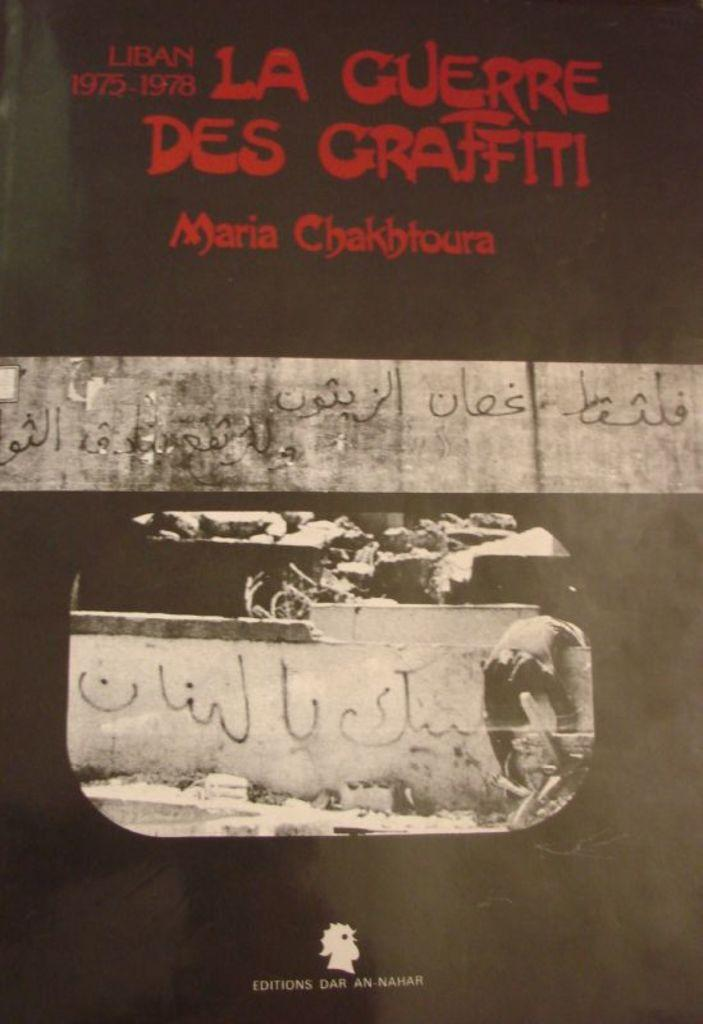<image>
Offer a succinct explanation of the picture presented. A book cover by Maria Chakbtoura has the years of 1975-1978 on it in read. 